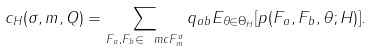<formula> <loc_0><loc_0><loc_500><loc_500>c _ { H } ( \sigma , m , Q ) = \sum _ { F _ { a } , F _ { b } \in \ m c { F } ^ { \sigma } _ { m } } q _ { a b } E _ { \theta \in \Theta _ { H } } [ p ( F _ { a } , F _ { b } , \theta ; H ) ] .</formula> 